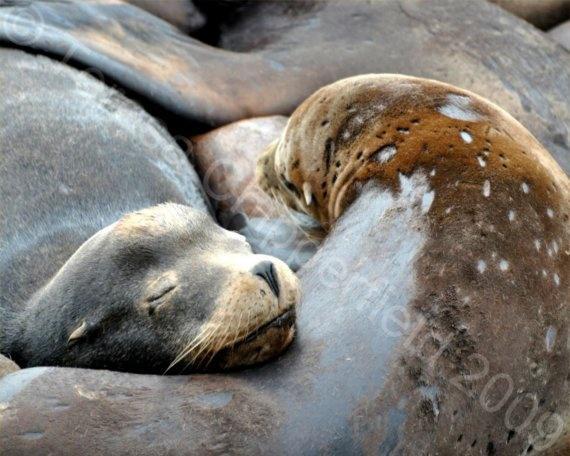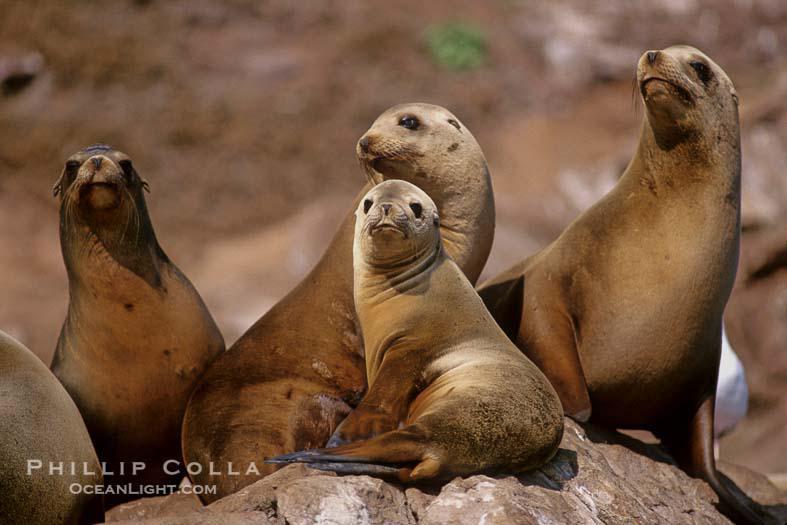The first image is the image on the left, the second image is the image on the right. Evaluate the accuracy of this statement regarding the images: "An image shows three seals sleeping side-by-side.". Is it true? Answer yes or no. No. The first image is the image on the left, the second image is the image on the right. For the images shown, is this caption "There are less than two sea mammals sunning in each of the images." true? Answer yes or no. No. 